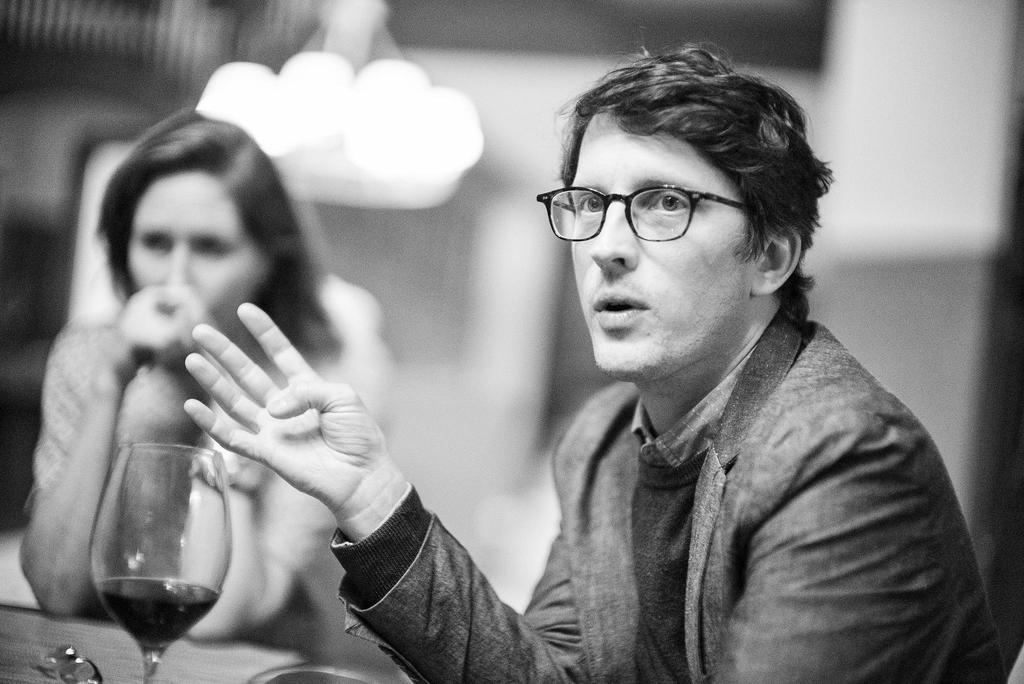What is the color scheme of the image? The image is black and white. How many people are present in the image? There are two people sitting in the image. Can you describe one of the men in the image? One of the men is wearing spectacles. What is located in front of the man with spectacles? There is a glass on a surface in front of the man with spectacles. How would you describe the background of the image? The background of the image is blurry. What shape is the receipt on the table in the image? There is no receipt present in the image; it is a black and white image of two people sitting with a blurry background. 